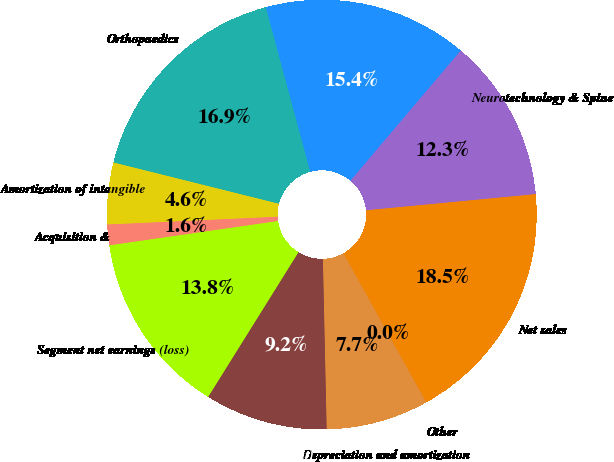<chart> <loc_0><loc_0><loc_500><loc_500><pie_chart><fcel>Orthopaedics<fcel>MedSurg<fcel>Neurotechnology & Spine<fcel>Net sales<fcel>Other<fcel>Depreciation and amortization<fcel>Income taxes (credit)<fcel>Segment net earnings (loss)<fcel>Acquisition &<fcel>Amortization of intangible<nl><fcel>16.91%<fcel>15.38%<fcel>12.3%<fcel>18.45%<fcel>0.01%<fcel>7.7%<fcel>9.23%<fcel>13.84%<fcel>1.55%<fcel>4.62%<nl></chart> 